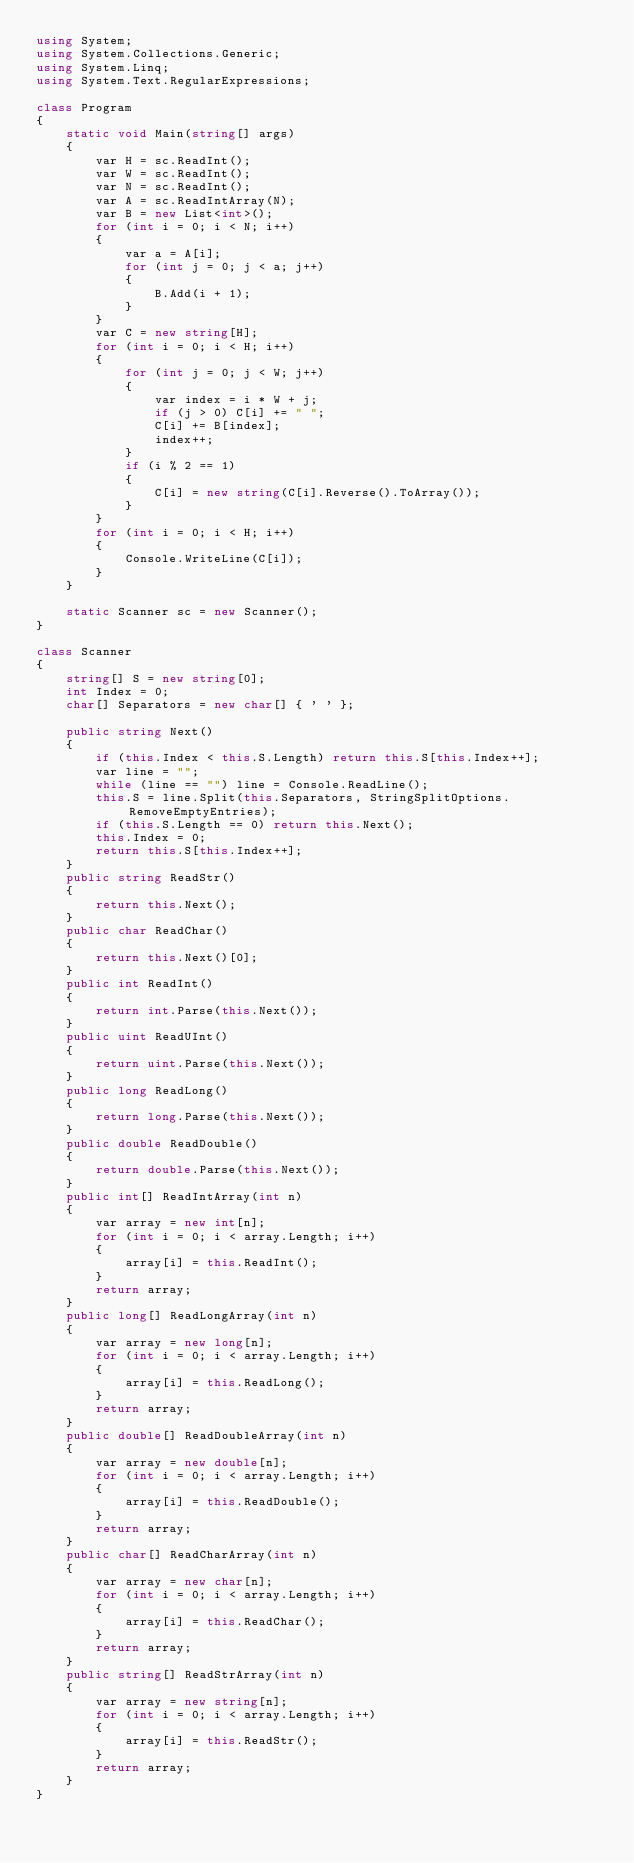Convert code to text. <code><loc_0><loc_0><loc_500><loc_500><_C#_>using System;
using System.Collections.Generic;
using System.Linq;
using System.Text.RegularExpressions;

class Program
{
    static void Main(string[] args)
    {
        var H = sc.ReadInt();
        var W = sc.ReadInt();
        var N = sc.ReadInt();
        var A = sc.ReadIntArray(N);
        var B = new List<int>();
        for (int i = 0; i < N; i++)
        {
            var a = A[i];
            for (int j = 0; j < a; j++)
            {
                B.Add(i + 1);
            }
        }
        var C = new string[H];
        for (int i = 0; i < H; i++)
        {
            for (int j = 0; j < W; j++)
            {
                var index = i * W + j;
                if (j > 0) C[i] += " ";
                C[i] += B[index];
                index++;
            }
            if (i % 2 == 1)
            {
                C[i] = new string(C[i].Reverse().ToArray());
            }
        }
        for (int i = 0; i < H; i++)
        {
            Console.WriteLine(C[i]);
        }
    }

    static Scanner sc = new Scanner();
}

class Scanner
{
    string[] S = new string[0];
    int Index = 0;
    char[] Separators = new char[] { ' ' };

    public string Next()
    {
        if (this.Index < this.S.Length) return this.S[this.Index++];
        var line = "";
        while (line == "") line = Console.ReadLine();
        this.S = line.Split(this.Separators, StringSplitOptions.RemoveEmptyEntries);
        if (this.S.Length == 0) return this.Next();
        this.Index = 0;
        return this.S[this.Index++];
    }
    public string ReadStr()
    {
        return this.Next();
    }
    public char ReadChar()
    {
        return this.Next()[0];
    }
    public int ReadInt()
    {
        return int.Parse(this.Next());
    }
    public uint ReadUInt()
    {
        return uint.Parse(this.Next());
    }
    public long ReadLong()
    {
        return long.Parse(this.Next());
    }
    public double ReadDouble()
    {
        return double.Parse(this.Next());
    }
    public int[] ReadIntArray(int n)
    {
        var array = new int[n];
        for (int i = 0; i < array.Length; i++)
        {
            array[i] = this.ReadInt();
        }
        return array;
    }
    public long[] ReadLongArray(int n)
    {
        var array = new long[n];
        for (int i = 0; i < array.Length; i++)
        {
            array[i] = this.ReadLong();
        }
        return array;
    }
    public double[] ReadDoubleArray(int n)
    {
        var array = new double[n];
        for (int i = 0; i < array.Length; i++)
        {
            array[i] = this.ReadDouble();
        }
        return array;
    }
    public char[] ReadCharArray(int n)
    {
        var array = new char[n];
        for (int i = 0; i < array.Length; i++)
        {
            array[i] = this.ReadChar();
        }
        return array;
    }
    public string[] ReadStrArray(int n)
    {
        var array = new string[n];
        for (int i = 0; i < array.Length; i++)
        {
            array[i] = this.ReadStr();
        }
        return array;
    }
}
</code> 